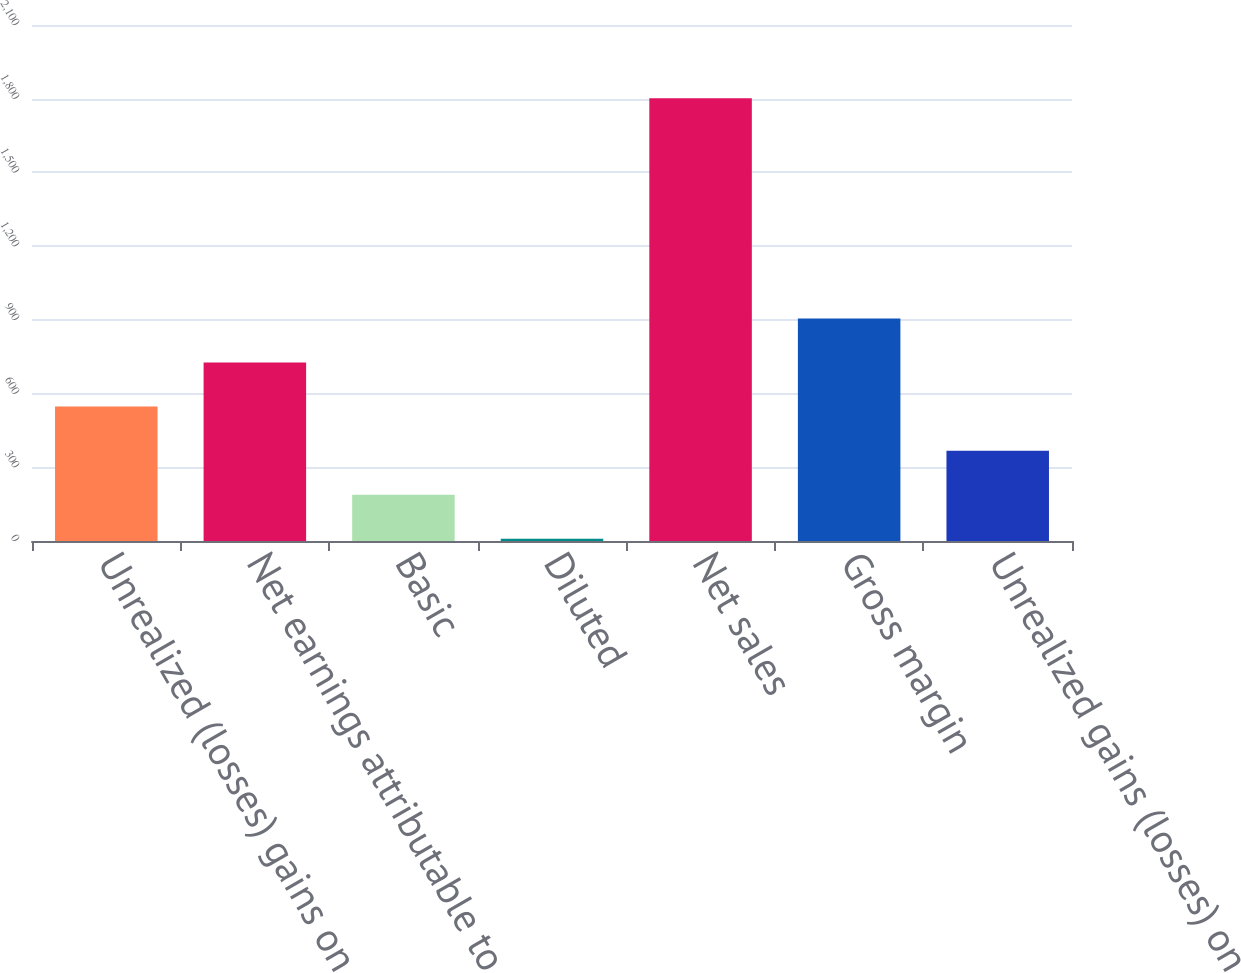Convert chart to OTSL. <chart><loc_0><loc_0><loc_500><loc_500><bar_chart><fcel>Unrealized (losses) gains on<fcel>Net earnings attributable to<fcel>Basic<fcel>Diluted<fcel>Net sales<fcel>Gross margin<fcel>Unrealized gains (losses) on<nl><fcel>547.03<fcel>726.27<fcel>188.55<fcel>9.31<fcel>1801.7<fcel>905.51<fcel>367.79<nl></chart> 